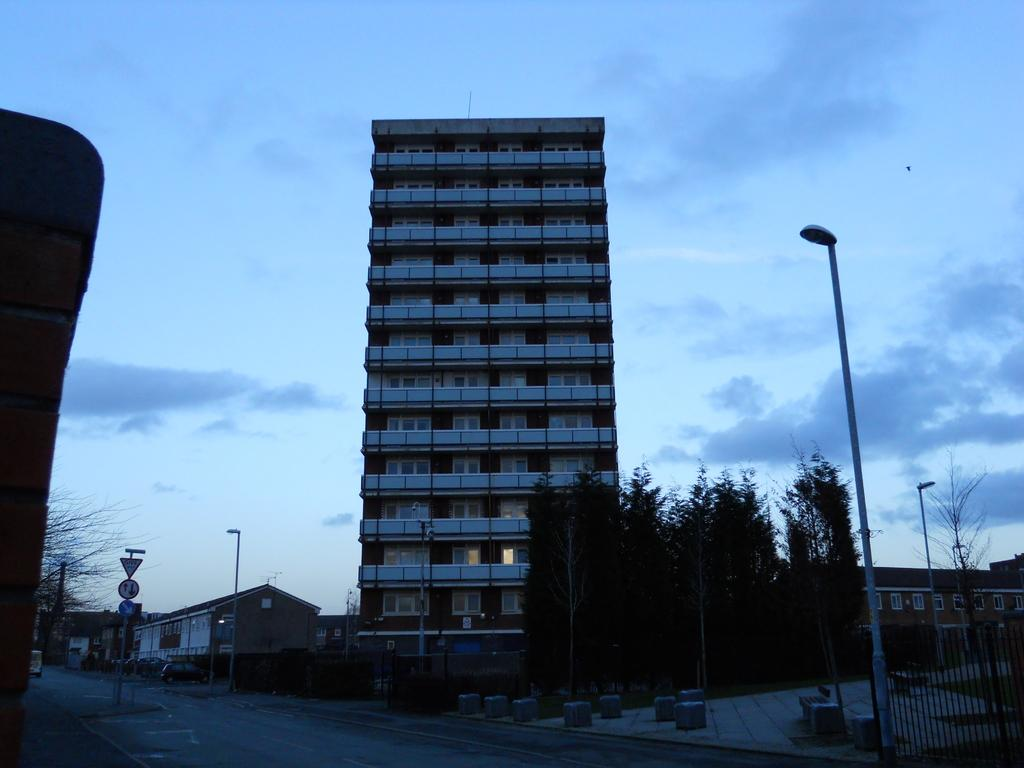What type of structure can be seen in the image? There is a building in the image. Are there any residential structures in the image? Yes, there are houses in the image. What type of vegetation is present in the image? There are trees in the image. What are the poles used for in the image? The poles are likely used for supporting sign boards or other infrastructure. What type of signage is visible in the image? There are sign boards in the image. What type of transportation can be seen in the image? There are vehicles in the image. What type of plant is present in the image? There is a plant in the image. What type of surface can be seen in the image? There is a road in the image. What type of cooking appliance is present in the image? There is a grill in the image. What can be seen in the background of the image? The sky is visible in the background of the image. Where is the expert located in the image? There is no expert present in the image. What type of coil is wrapped around the trees in the image? There are no coils wrapped around the trees in the image. 